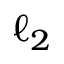Convert formula to latex. <formula><loc_0><loc_0><loc_500><loc_500>\ell _ { 2 }</formula> 